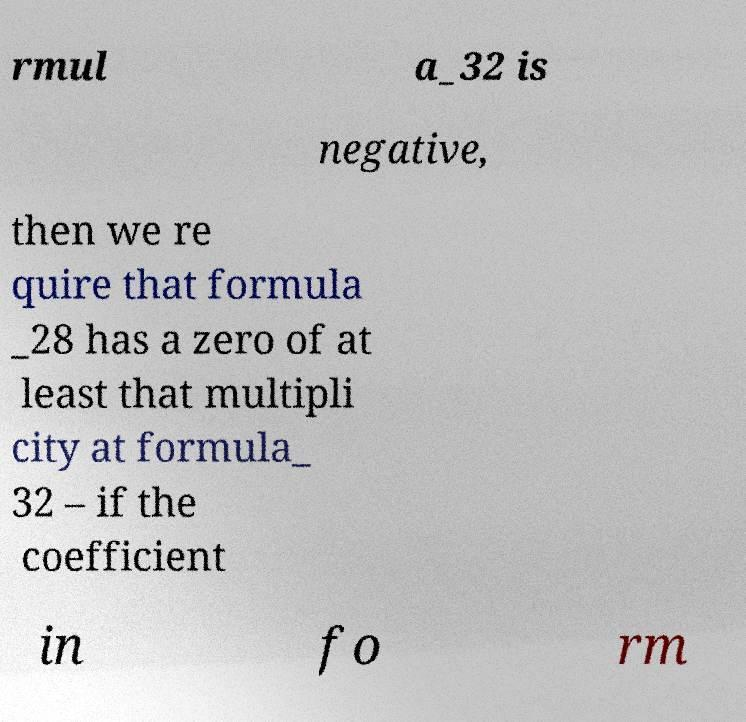Can you accurately transcribe the text from the provided image for me? rmul a_32 is negative, then we re quire that formula _28 has a zero of at least that multipli city at formula_ 32 – if the coefficient in fo rm 